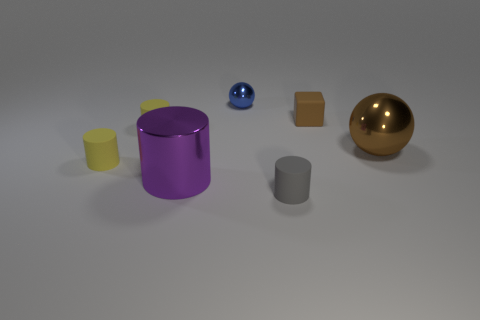What number of things are things that are behind the large sphere or small cylinders?
Offer a terse response. 5. There is a brown cube that is the same size as the gray cylinder; what is it made of?
Offer a very short reply. Rubber. The rubber cylinder that is behind the small yellow rubber thing in front of the large brown sphere is what color?
Offer a very short reply. Yellow. What number of tiny gray cylinders are in front of the brown metallic sphere?
Provide a short and direct response. 1. What color is the small block?
Keep it short and to the point. Brown. What number of tiny things are either purple cylinders or yellow objects?
Your answer should be very brief. 2. Is the color of the big object right of the small brown thing the same as the tiny rubber cube that is behind the small gray cylinder?
Give a very brief answer. Yes. What number of other things are there of the same color as the tiny block?
Offer a very short reply. 1. What is the shape of the metallic object that is to the left of the tiny blue metal ball?
Keep it short and to the point. Cylinder. Is the number of big shiny cylinders less than the number of big brown metal cubes?
Your response must be concise. No. 